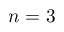<formula> <loc_0><loc_0><loc_500><loc_500>n = 3</formula> 